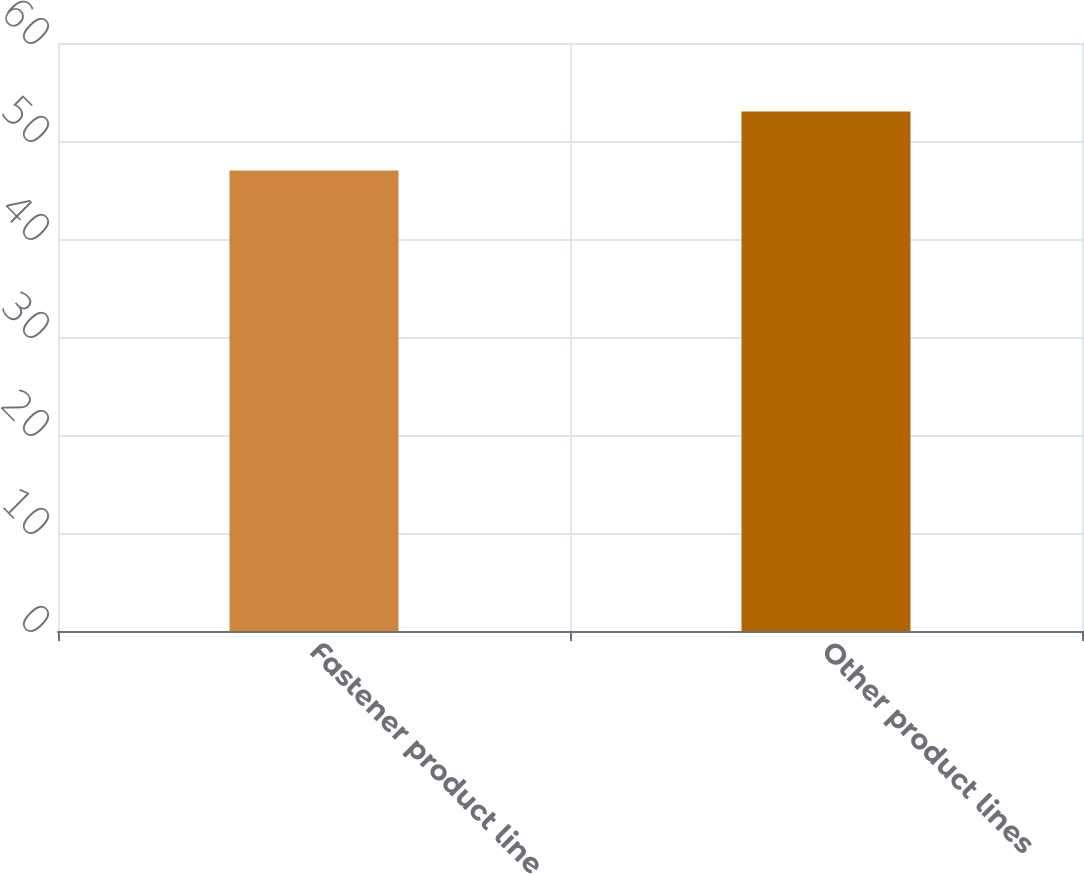Convert chart to OTSL. <chart><loc_0><loc_0><loc_500><loc_500><bar_chart><fcel>Fastener product line<fcel>Other product lines<nl><fcel>47<fcel>53<nl></chart> 